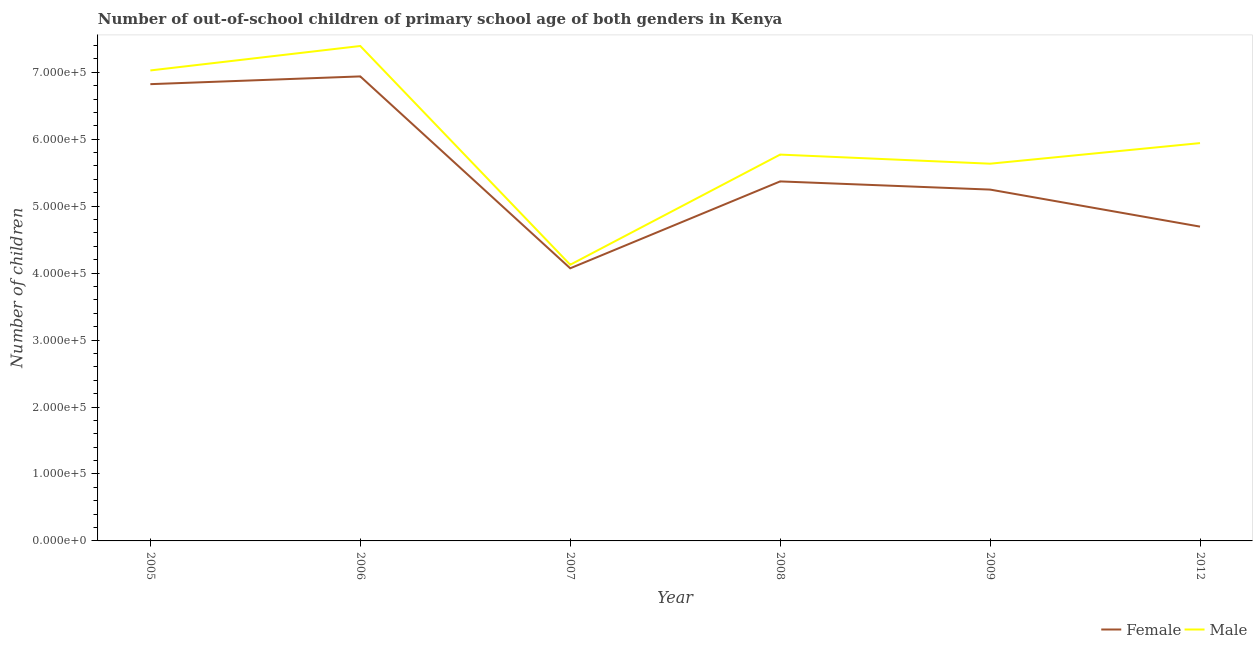How many different coloured lines are there?
Provide a succinct answer. 2. Does the line corresponding to number of male out-of-school students intersect with the line corresponding to number of female out-of-school students?
Ensure brevity in your answer.  No. Is the number of lines equal to the number of legend labels?
Your answer should be compact. Yes. What is the number of male out-of-school students in 2005?
Ensure brevity in your answer.  7.03e+05. Across all years, what is the maximum number of male out-of-school students?
Your answer should be very brief. 7.39e+05. Across all years, what is the minimum number of female out-of-school students?
Offer a terse response. 4.07e+05. In which year was the number of female out-of-school students minimum?
Offer a very short reply. 2007. What is the total number of male out-of-school students in the graph?
Your answer should be very brief. 3.59e+06. What is the difference between the number of female out-of-school students in 2005 and that in 2008?
Your answer should be compact. 1.45e+05. What is the difference between the number of male out-of-school students in 2009 and the number of female out-of-school students in 2006?
Make the answer very short. -1.30e+05. What is the average number of female out-of-school students per year?
Keep it short and to the point. 5.52e+05. In the year 2006, what is the difference between the number of female out-of-school students and number of male out-of-school students?
Ensure brevity in your answer.  -4.54e+04. What is the ratio of the number of female out-of-school students in 2008 to that in 2009?
Ensure brevity in your answer.  1.02. Is the difference between the number of male out-of-school students in 2005 and 2007 greater than the difference between the number of female out-of-school students in 2005 and 2007?
Your response must be concise. Yes. What is the difference between the highest and the second highest number of male out-of-school students?
Provide a succinct answer. 3.65e+04. What is the difference between the highest and the lowest number of female out-of-school students?
Ensure brevity in your answer.  2.87e+05. In how many years, is the number of female out-of-school students greater than the average number of female out-of-school students taken over all years?
Your response must be concise. 2. Does the number of male out-of-school students monotonically increase over the years?
Ensure brevity in your answer.  No. Is the number of female out-of-school students strictly less than the number of male out-of-school students over the years?
Give a very brief answer. Yes. Are the values on the major ticks of Y-axis written in scientific E-notation?
Your answer should be compact. Yes. Where does the legend appear in the graph?
Your answer should be very brief. Bottom right. How many legend labels are there?
Your response must be concise. 2. How are the legend labels stacked?
Your answer should be compact. Horizontal. What is the title of the graph?
Give a very brief answer. Number of out-of-school children of primary school age of both genders in Kenya. What is the label or title of the X-axis?
Provide a succinct answer. Year. What is the label or title of the Y-axis?
Your answer should be compact. Number of children. What is the Number of children of Female in 2005?
Offer a terse response. 6.82e+05. What is the Number of children in Male in 2005?
Provide a succinct answer. 7.03e+05. What is the Number of children of Female in 2006?
Keep it short and to the point. 6.94e+05. What is the Number of children of Male in 2006?
Ensure brevity in your answer.  7.39e+05. What is the Number of children of Female in 2007?
Give a very brief answer. 4.07e+05. What is the Number of children of Male in 2007?
Your answer should be compact. 4.12e+05. What is the Number of children of Female in 2008?
Make the answer very short. 5.37e+05. What is the Number of children in Male in 2008?
Make the answer very short. 5.77e+05. What is the Number of children of Female in 2009?
Your answer should be compact. 5.25e+05. What is the Number of children of Male in 2009?
Make the answer very short. 5.63e+05. What is the Number of children in Female in 2012?
Provide a succinct answer. 4.69e+05. What is the Number of children in Male in 2012?
Keep it short and to the point. 5.94e+05. Across all years, what is the maximum Number of children in Female?
Offer a very short reply. 6.94e+05. Across all years, what is the maximum Number of children in Male?
Provide a short and direct response. 7.39e+05. Across all years, what is the minimum Number of children of Female?
Offer a terse response. 4.07e+05. Across all years, what is the minimum Number of children in Male?
Your answer should be compact. 4.12e+05. What is the total Number of children in Female in the graph?
Make the answer very short. 3.31e+06. What is the total Number of children of Male in the graph?
Provide a succinct answer. 3.59e+06. What is the difference between the Number of children of Female in 2005 and that in 2006?
Offer a terse response. -1.16e+04. What is the difference between the Number of children in Male in 2005 and that in 2006?
Your response must be concise. -3.65e+04. What is the difference between the Number of children in Female in 2005 and that in 2007?
Make the answer very short. 2.75e+05. What is the difference between the Number of children in Male in 2005 and that in 2007?
Ensure brevity in your answer.  2.90e+05. What is the difference between the Number of children in Female in 2005 and that in 2008?
Your answer should be very brief. 1.45e+05. What is the difference between the Number of children in Male in 2005 and that in 2008?
Your answer should be very brief. 1.26e+05. What is the difference between the Number of children in Female in 2005 and that in 2009?
Provide a short and direct response. 1.57e+05. What is the difference between the Number of children in Male in 2005 and that in 2009?
Keep it short and to the point. 1.39e+05. What is the difference between the Number of children of Female in 2005 and that in 2012?
Offer a terse response. 2.13e+05. What is the difference between the Number of children of Male in 2005 and that in 2012?
Your response must be concise. 1.09e+05. What is the difference between the Number of children in Female in 2006 and that in 2007?
Your response must be concise. 2.87e+05. What is the difference between the Number of children of Male in 2006 and that in 2007?
Offer a very short reply. 3.27e+05. What is the difference between the Number of children in Female in 2006 and that in 2008?
Offer a terse response. 1.57e+05. What is the difference between the Number of children of Male in 2006 and that in 2008?
Offer a terse response. 1.62e+05. What is the difference between the Number of children of Female in 2006 and that in 2009?
Provide a succinct answer. 1.69e+05. What is the difference between the Number of children in Male in 2006 and that in 2009?
Offer a very short reply. 1.76e+05. What is the difference between the Number of children in Female in 2006 and that in 2012?
Ensure brevity in your answer.  2.24e+05. What is the difference between the Number of children in Male in 2006 and that in 2012?
Make the answer very short. 1.45e+05. What is the difference between the Number of children in Female in 2007 and that in 2008?
Your response must be concise. -1.30e+05. What is the difference between the Number of children in Male in 2007 and that in 2008?
Keep it short and to the point. -1.65e+05. What is the difference between the Number of children of Female in 2007 and that in 2009?
Provide a short and direct response. -1.18e+05. What is the difference between the Number of children of Male in 2007 and that in 2009?
Give a very brief answer. -1.51e+05. What is the difference between the Number of children in Female in 2007 and that in 2012?
Ensure brevity in your answer.  -6.23e+04. What is the difference between the Number of children of Male in 2007 and that in 2012?
Ensure brevity in your answer.  -1.82e+05. What is the difference between the Number of children in Female in 2008 and that in 2009?
Offer a very short reply. 1.22e+04. What is the difference between the Number of children of Male in 2008 and that in 2009?
Ensure brevity in your answer.  1.36e+04. What is the difference between the Number of children in Female in 2008 and that in 2012?
Ensure brevity in your answer.  6.75e+04. What is the difference between the Number of children of Male in 2008 and that in 2012?
Provide a short and direct response. -1.72e+04. What is the difference between the Number of children of Female in 2009 and that in 2012?
Your response must be concise. 5.53e+04. What is the difference between the Number of children of Male in 2009 and that in 2012?
Keep it short and to the point. -3.08e+04. What is the difference between the Number of children of Female in 2005 and the Number of children of Male in 2006?
Make the answer very short. -5.70e+04. What is the difference between the Number of children in Female in 2005 and the Number of children in Male in 2007?
Your response must be concise. 2.70e+05. What is the difference between the Number of children in Female in 2005 and the Number of children in Male in 2008?
Ensure brevity in your answer.  1.05e+05. What is the difference between the Number of children in Female in 2005 and the Number of children in Male in 2009?
Ensure brevity in your answer.  1.19e+05. What is the difference between the Number of children in Female in 2005 and the Number of children in Male in 2012?
Your answer should be compact. 8.80e+04. What is the difference between the Number of children of Female in 2006 and the Number of children of Male in 2007?
Provide a succinct answer. 2.81e+05. What is the difference between the Number of children of Female in 2006 and the Number of children of Male in 2008?
Offer a very short reply. 1.17e+05. What is the difference between the Number of children of Female in 2006 and the Number of children of Male in 2009?
Offer a very short reply. 1.30e+05. What is the difference between the Number of children of Female in 2006 and the Number of children of Male in 2012?
Ensure brevity in your answer.  9.96e+04. What is the difference between the Number of children of Female in 2007 and the Number of children of Male in 2008?
Provide a short and direct response. -1.70e+05. What is the difference between the Number of children in Female in 2007 and the Number of children in Male in 2009?
Keep it short and to the point. -1.56e+05. What is the difference between the Number of children of Female in 2007 and the Number of children of Male in 2012?
Your answer should be compact. -1.87e+05. What is the difference between the Number of children in Female in 2008 and the Number of children in Male in 2009?
Provide a succinct answer. -2.65e+04. What is the difference between the Number of children of Female in 2008 and the Number of children of Male in 2012?
Provide a succinct answer. -5.72e+04. What is the difference between the Number of children of Female in 2009 and the Number of children of Male in 2012?
Ensure brevity in your answer.  -6.94e+04. What is the average Number of children in Female per year?
Your answer should be compact. 5.52e+05. What is the average Number of children of Male per year?
Your response must be concise. 5.98e+05. In the year 2005, what is the difference between the Number of children of Female and Number of children of Male?
Keep it short and to the point. -2.05e+04. In the year 2006, what is the difference between the Number of children of Female and Number of children of Male?
Make the answer very short. -4.54e+04. In the year 2007, what is the difference between the Number of children in Female and Number of children in Male?
Keep it short and to the point. -5304. In the year 2008, what is the difference between the Number of children of Female and Number of children of Male?
Ensure brevity in your answer.  -4.01e+04. In the year 2009, what is the difference between the Number of children in Female and Number of children in Male?
Your answer should be very brief. -3.87e+04. In the year 2012, what is the difference between the Number of children of Female and Number of children of Male?
Provide a short and direct response. -1.25e+05. What is the ratio of the Number of children in Female in 2005 to that in 2006?
Your response must be concise. 0.98. What is the ratio of the Number of children in Male in 2005 to that in 2006?
Your response must be concise. 0.95. What is the ratio of the Number of children of Female in 2005 to that in 2007?
Your response must be concise. 1.68. What is the ratio of the Number of children of Male in 2005 to that in 2007?
Offer a very short reply. 1.7. What is the ratio of the Number of children of Female in 2005 to that in 2008?
Make the answer very short. 1.27. What is the ratio of the Number of children of Male in 2005 to that in 2008?
Ensure brevity in your answer.  1.22. What is the ratio of the Number of children of Female in 2005 to that in 2009?
Provide a succinct answer. 1.3. What is the ratio of the Number of children of Male in 2005 to that in 2009?
Your response must be concise. 1.25. What is the ratio of the Number of children of Female in 2005 to that in 2012?
Give a very brief answer. 1.45. What is the ratio of the Number of children of Male in 2005 to that in 2012?
Offer a terse response. 1.18. What is the ratio of the Number of children in Female in 2006 to that in 2007?
Provide a short and direct response. 1.7. What is the ratio of the Number of children in Male in 2006 to that in 2007?
Make the answer very short. 1.79. What is the ratio of the Number of children in Female in 2006 to that in 2008?
Give a very brief answer. 1.29. What is the ratio of the Number of children in Male in 2006 to that in 2008?
Provide a succinct answer. 1.28. What is the ratio of the Number of children in Female in 2006 to that in 2009?
Your answer should be compact. 1.32. What is the ratio of the Number of children of Male in 2006 to that in 2009?
Give a very brief answer. 1.31. What is the ratio of the Number of children of Female in 2006 to that in 2012?
Keep it short and to the point. 1.48. What is the ratio of the Number of children of Male in 2006 to that in 2012?
Your response must be concise. 1.24. What is the ratio of the Number of children of Female in 2007 to that in 2008?
Keep it short and to the point. 0.76. What is the ratio of the Number of children of Male in 2007 to that in 2008?
Offer a terse response. 0.71. What is the ratio of the Number of children of Female in 2007 to that in 2009?
Give a very brief answer. 0.78. What is the ratio of the Number of children of Male in 2007 to that in 2009?
Ensure brevity in your answer.  0.73. What is the ratio of the Number of children of Female in 2007 to that in 2012?
Provide a short and direct response. 0.87. What is the ratio of the Number of children of Male in 2007 to that in 2012?
Give a very brief answer. 0.69. What is the ratio of the Number of children in Female in 2008 to that in 2009?
Your answer should be very brief. 1.02. What is the ratio of the Number of children in Male in 2008 to that in 2009?
Make the answer very short. 1.02. What is the ratio of the Number of children in Female in 2008 to that in 2012?
Ensure brevity in your answer.  1.14. What is the ratio of the Number of children in Male in 2008 to that in 2012?
Offer a terse response. 0.97. What is the ratio of the Number of children of Female in 2009 to that in 2012?
Provide a short and direct response. 1.12. What is the ratio of the Number of children of Male in 2009 to that in 2012?
Provide a succinct answer. 0.95. What is the difference between the highest and the second highest Number of children of Female?
Provide a succinct answer. 1.16e+04. What is the difference between the highest and the second highest Number of children of Male?
Your answer should be very brief. 3.65e+04. What is the difference between the highest and the lowest Number of children in Female?
Ensure brevity in your answer.  2.87e+05. What is the difference between the highest and the lowest Number of children in Male?
Ensure brevity in your answer.  3.27e+05. 